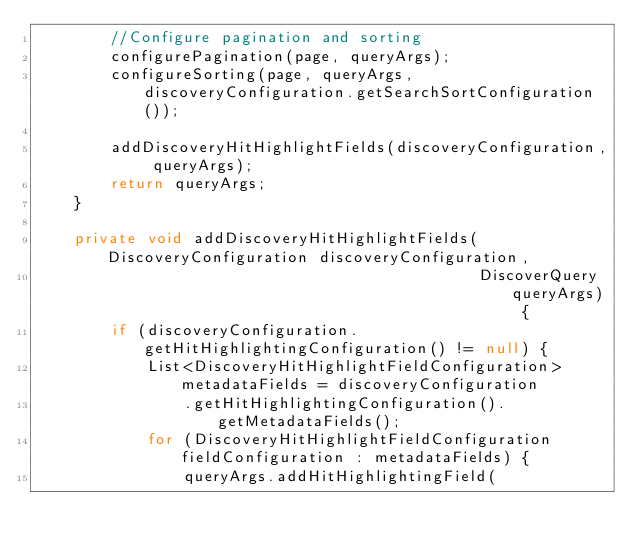<code> <loc_0><loc_0><loc_500><loc_500><_Java_>        //Configure pagination and sorting
        configurePagination(page, queryArgs);
        configureSorting(page, queryArgs, discoveryConfiguration.getSearchSortConfiguration());

        addDiscoveryHitHighlightFields(discoveryConfiguration, queryArgs);
        return queryArgs;
    }

    private void addDiscoveryHitHighlightFields(DiscoveryConfiguration discoveryConfiguration,
                                                DiscoverQuery queryArgs) {
        if (discoveryConfiguration.getHitHighlightingConfiguration() != null) {
            List<DiscoveryHitHighlightFieldConfiguration> metadataFields = discoveryConfiguration
                .getHitHighlightingConfiguration().getMetadataFields();
            for (DiscoveryHitHighlightFieldConfiguration fieldConfiguration : metadataFields) {
                queryArgs.addHitHighlightingField(</code> 